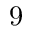<formula> <loc_0><loc_0><loc_500><loc_500>9</formula> 